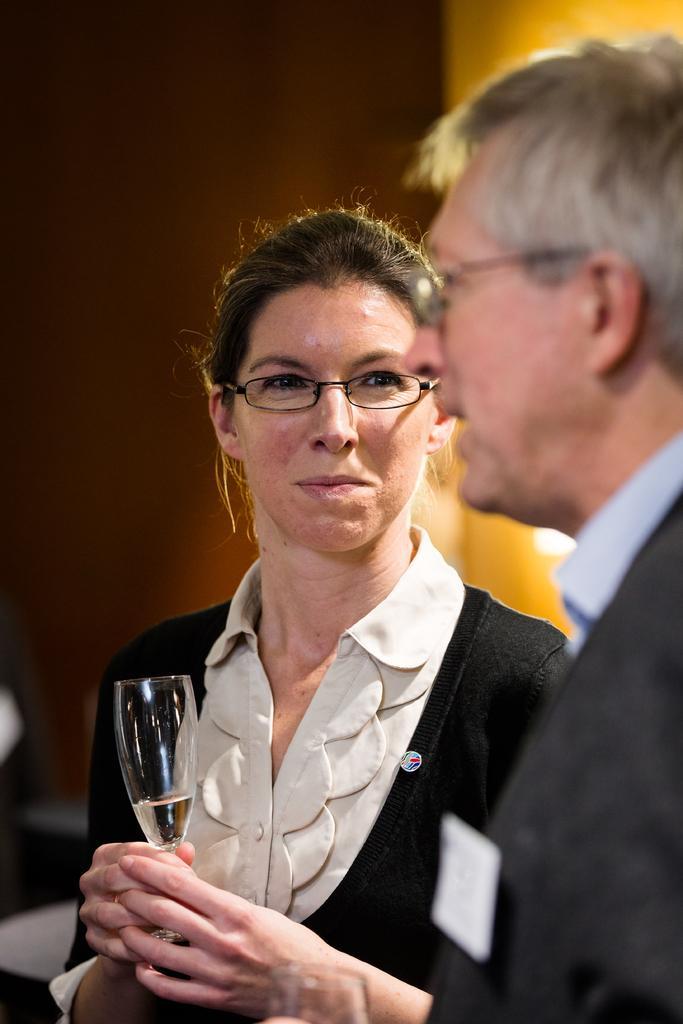Can you describe this image briefly? This picture shows a woman and man holding wine glass in their hands and speaking to each other. 